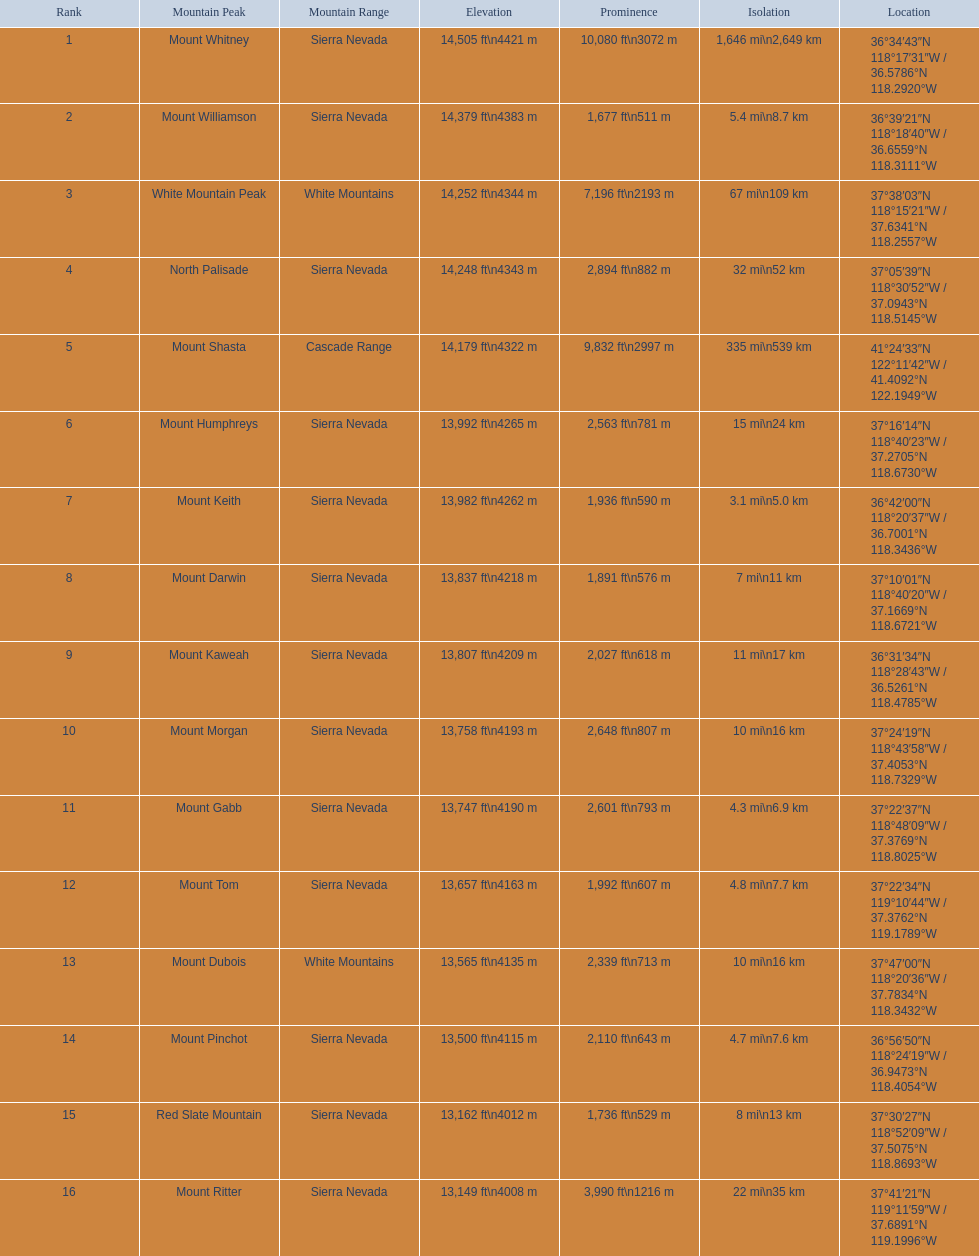Which mountain tops have a prominence above 9,000 ft? Mount Whitney, Mount Shasta. Of these, which one has the highest prominence? Mount Whitney. 